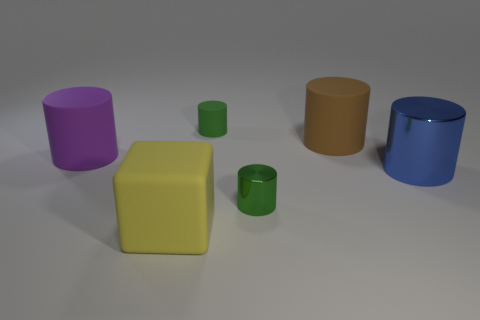Does the rubber cube have the same color as the tiny shiny cylinder?
Make the answer very short. No. There is another object that is the same color as the tiny metallic thing; what is its material?
Give a very brief answer. Rubber. How many other big brown rubber objects are the same shape as the brown thing?
Give a very brief answer. 0. Is the material of the large blue cylinder the same as the small green cylinder behind the purple matte thing?
Your response must be concise. No. There is a cylinder that is the same size as the green metallic thing; what material is it?
Your answer should be very brief. Rubber. Are there any cylinders of the same size as the green shiny thing?
Offer a very short reply. Yes. The yellow matte object that is the same size as the purple matte thing is what shape?
Offer a very short reply. Cube. What number of other objects are there of the same color as the small shiny object?
Make the answer very short. 1. What is the shape of the object that is both to the right of the green shiny object and behind the large purple matte thing?
Provide a short and direct response. Cylinder. Are there any large rubber cylinders that are on the left side of the big rubber thing to the right of the green cylinder in front of the blue object?
Ensure brevity in your answer.  Yes. 